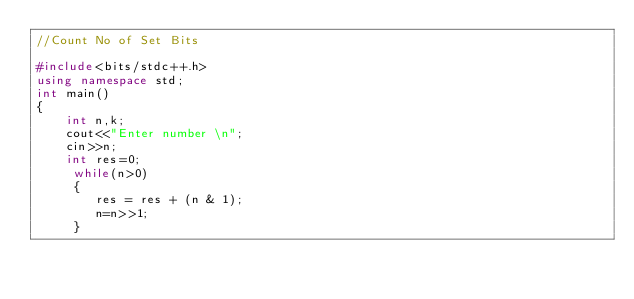Convert code to text. <code><loc_0><loc_0><loc_500><loc_500><_C++_>//Count No of Set Bits

#include<bits/stdc++.h>
using namespace std;
int main()
{
	int n,k;
	cout<<"Enter number \n";
	cin>>n;
	int res=0;
     while(n>0)
     {
     	res = res + (n & 1);
     	n=n>>1;
	 }</code> 